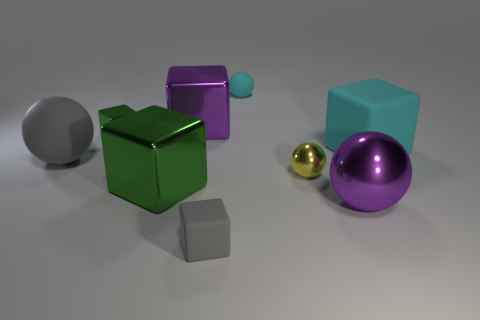Can you describe the lighting and shadows visible in the scene? The lighting in the scene is soft and diffused, with a source that seems to come from the upper left side, as indicated by the shadows cast to the lower right of the objects. The shadows are soft-edged and elongated, suggesting that the light source is not very close to the objects. 